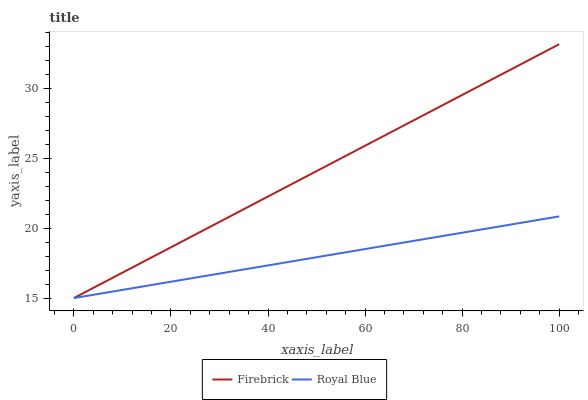Does Royal Blue have the minimum area under the curve?
Answer yes or no. Yes. Does Firebrick have the maximum area under the curve?
Answer yes or no. Yes. Does Firebrick have the minimum area under the curve?
Answer yes or no. No. Is Royal Blue the smoothest?
Answer yes or no. Yes. Is Firebrick the roughest?
Answer yes or no. Yes. Is Firebrick the smoothest?
Answer yes or no. No. Does Royal Blue have the lowest value?
Answer yes or no. Yes. Does Firebrick have the highest value?
Answer yes or no. Yes. Does Royal Blue intersect Firebrick?
Answer yes or no. Yes. Is Royal Blue less than Firebrick?
Answer yes or no. No. Is Royal Blue greater than Firebrick?
Answer yes or no. No. 